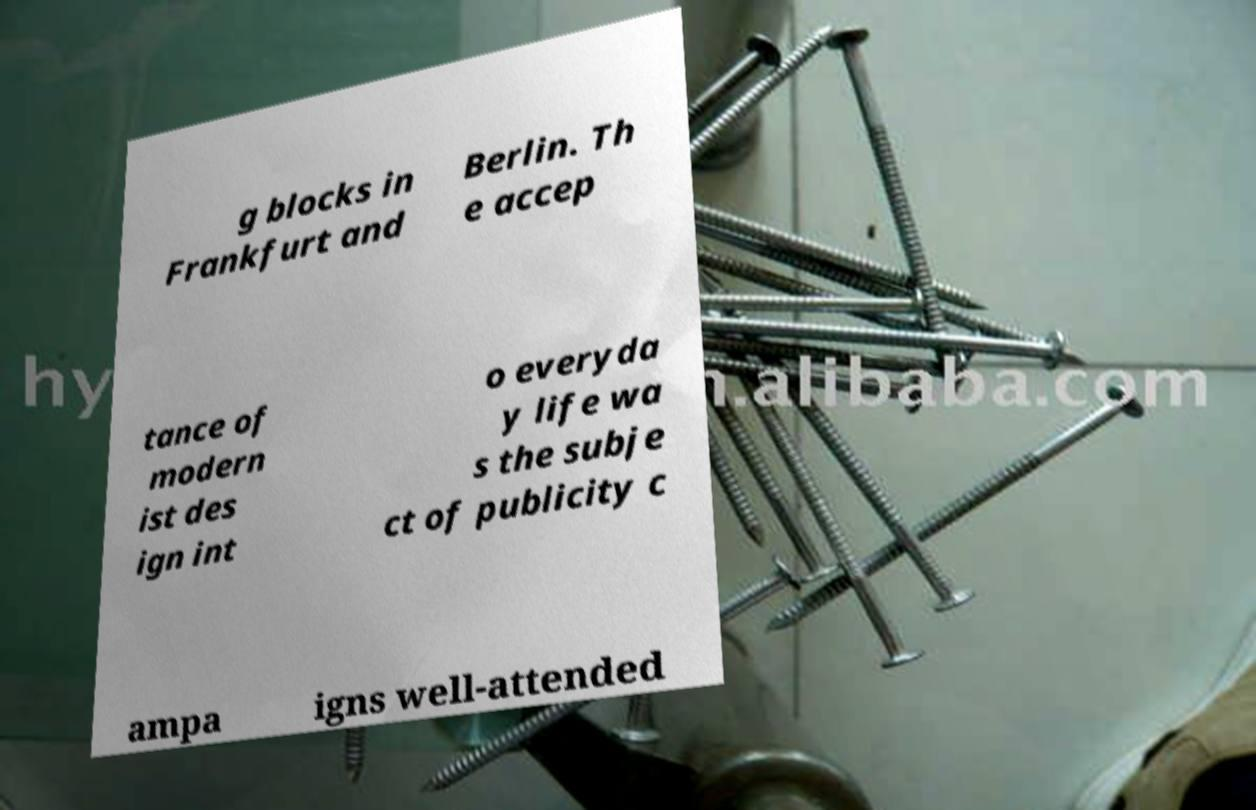Can you accurately transcribe the text from the provided image for me? g blocks in Frankfurt and Berlin. Th e accep tance of modern ist des ign int o everyda y life wa s the subje ct of publicity c ampa igns well-attended 